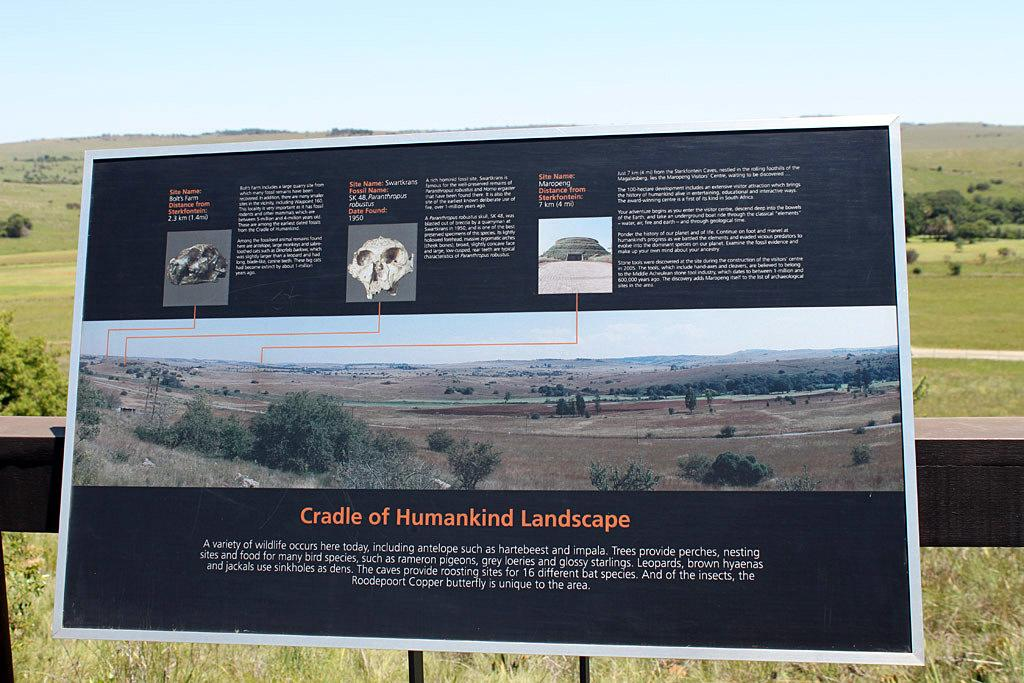<image>
Relay a brief, clear account of the picture shown. A sign talking about how this is the cradle of human kind. 